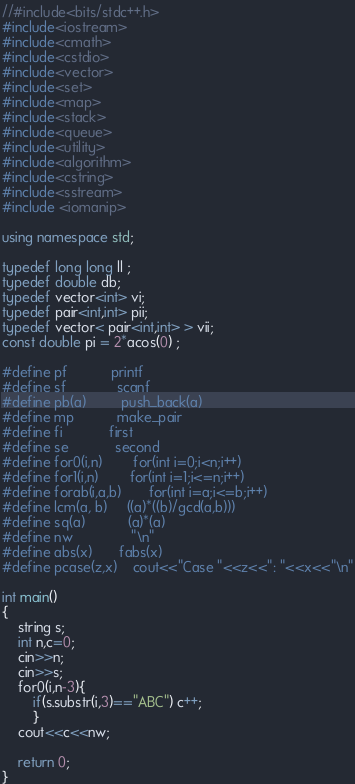Convert code to text. <code><loc_0><loc_0><loc_500><loc_500><_C++_>//#include<bits/stdc++.h>
#include<iostream>
#include<cmath>
#include<cstdio>
#include<vector>
#include<set>
#include<map>
#include<stack>
#include<queue>
#include<utility>
#include<algorithm>
#include<cstring>
#include<sstream>
#include <iomanip>

using namespace std;

typedef long long ll ;
typedef double db;
typedef vector<int> vi;
typedef pair<int,int> pii;
typedef vector< pair<int,int> > vii;
const double pi = 2*acos(0) ;

#define pf		  	printf
#define sf			  scanf
#define pb(a)         push_back(a)
#define mp			make_pair
#define fi			 first
#define se			 second
#define for0(i,n)        for(int i=0;i<n;i++)
#define for1(i,n)        for(int i=1;i<=n;i++)
#define forab(i,a,b)       for(int i=a;i<=b;i++)
#define lcm(a, b)     ((a)*((b)/gcd(a,b)))
#define sq(a)		   (a)*(a)
#define nw				"\n"
#define abs(x)		fabs(x)
#define pcase(z,x)    cout<<"Case "<<z<<": "<<x<<"\n"

int main()
{
	string s;
	int n,c=0;
	cin>>n;
	cin>>s;
	for0(i,n-3){
		if(s.substr(i,3)=="ABC") c++;
		}
	cout<<c<<nw;
	
	return 0;
}</code> 